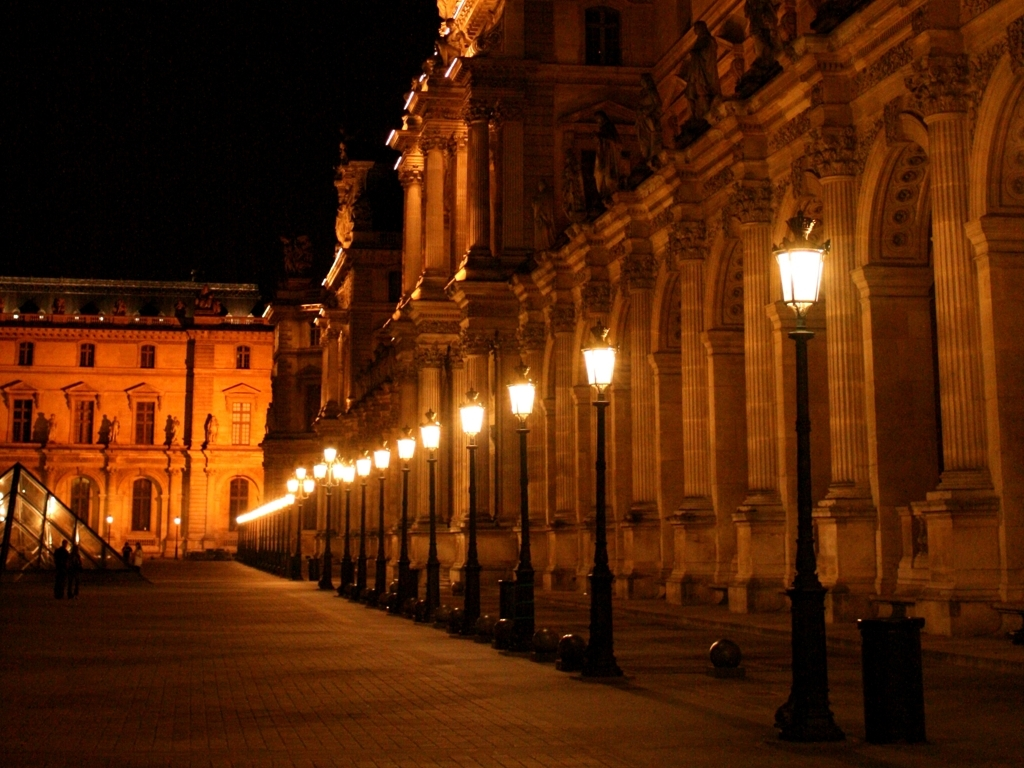Can you describe the ambiance of this place based on the lighting and time? The image conveys a serene and majestic ambiance, accentuated by the golden glow of the street lamps against the night sky. The soft illumination enhances the grandiosity of the architecture while invoking an intimate, almost tranquil atmosphere. 